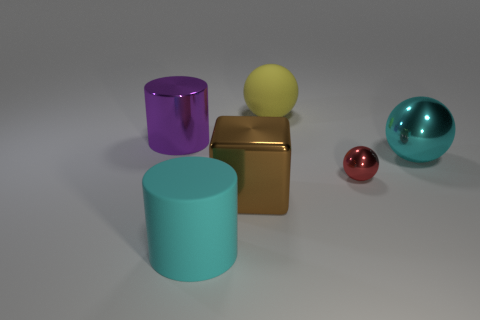What materials do the objects in the image appear to be made of? The objects in the image appear to be made of different materials with a metallic look. The cylinder on the left seems to have a matte finish, possibly resembling plastic or painted metal, whereas the cube, the sphere to its right, and the object on the far right have reflective surfaces, suggesting they could be made of polished metal. 